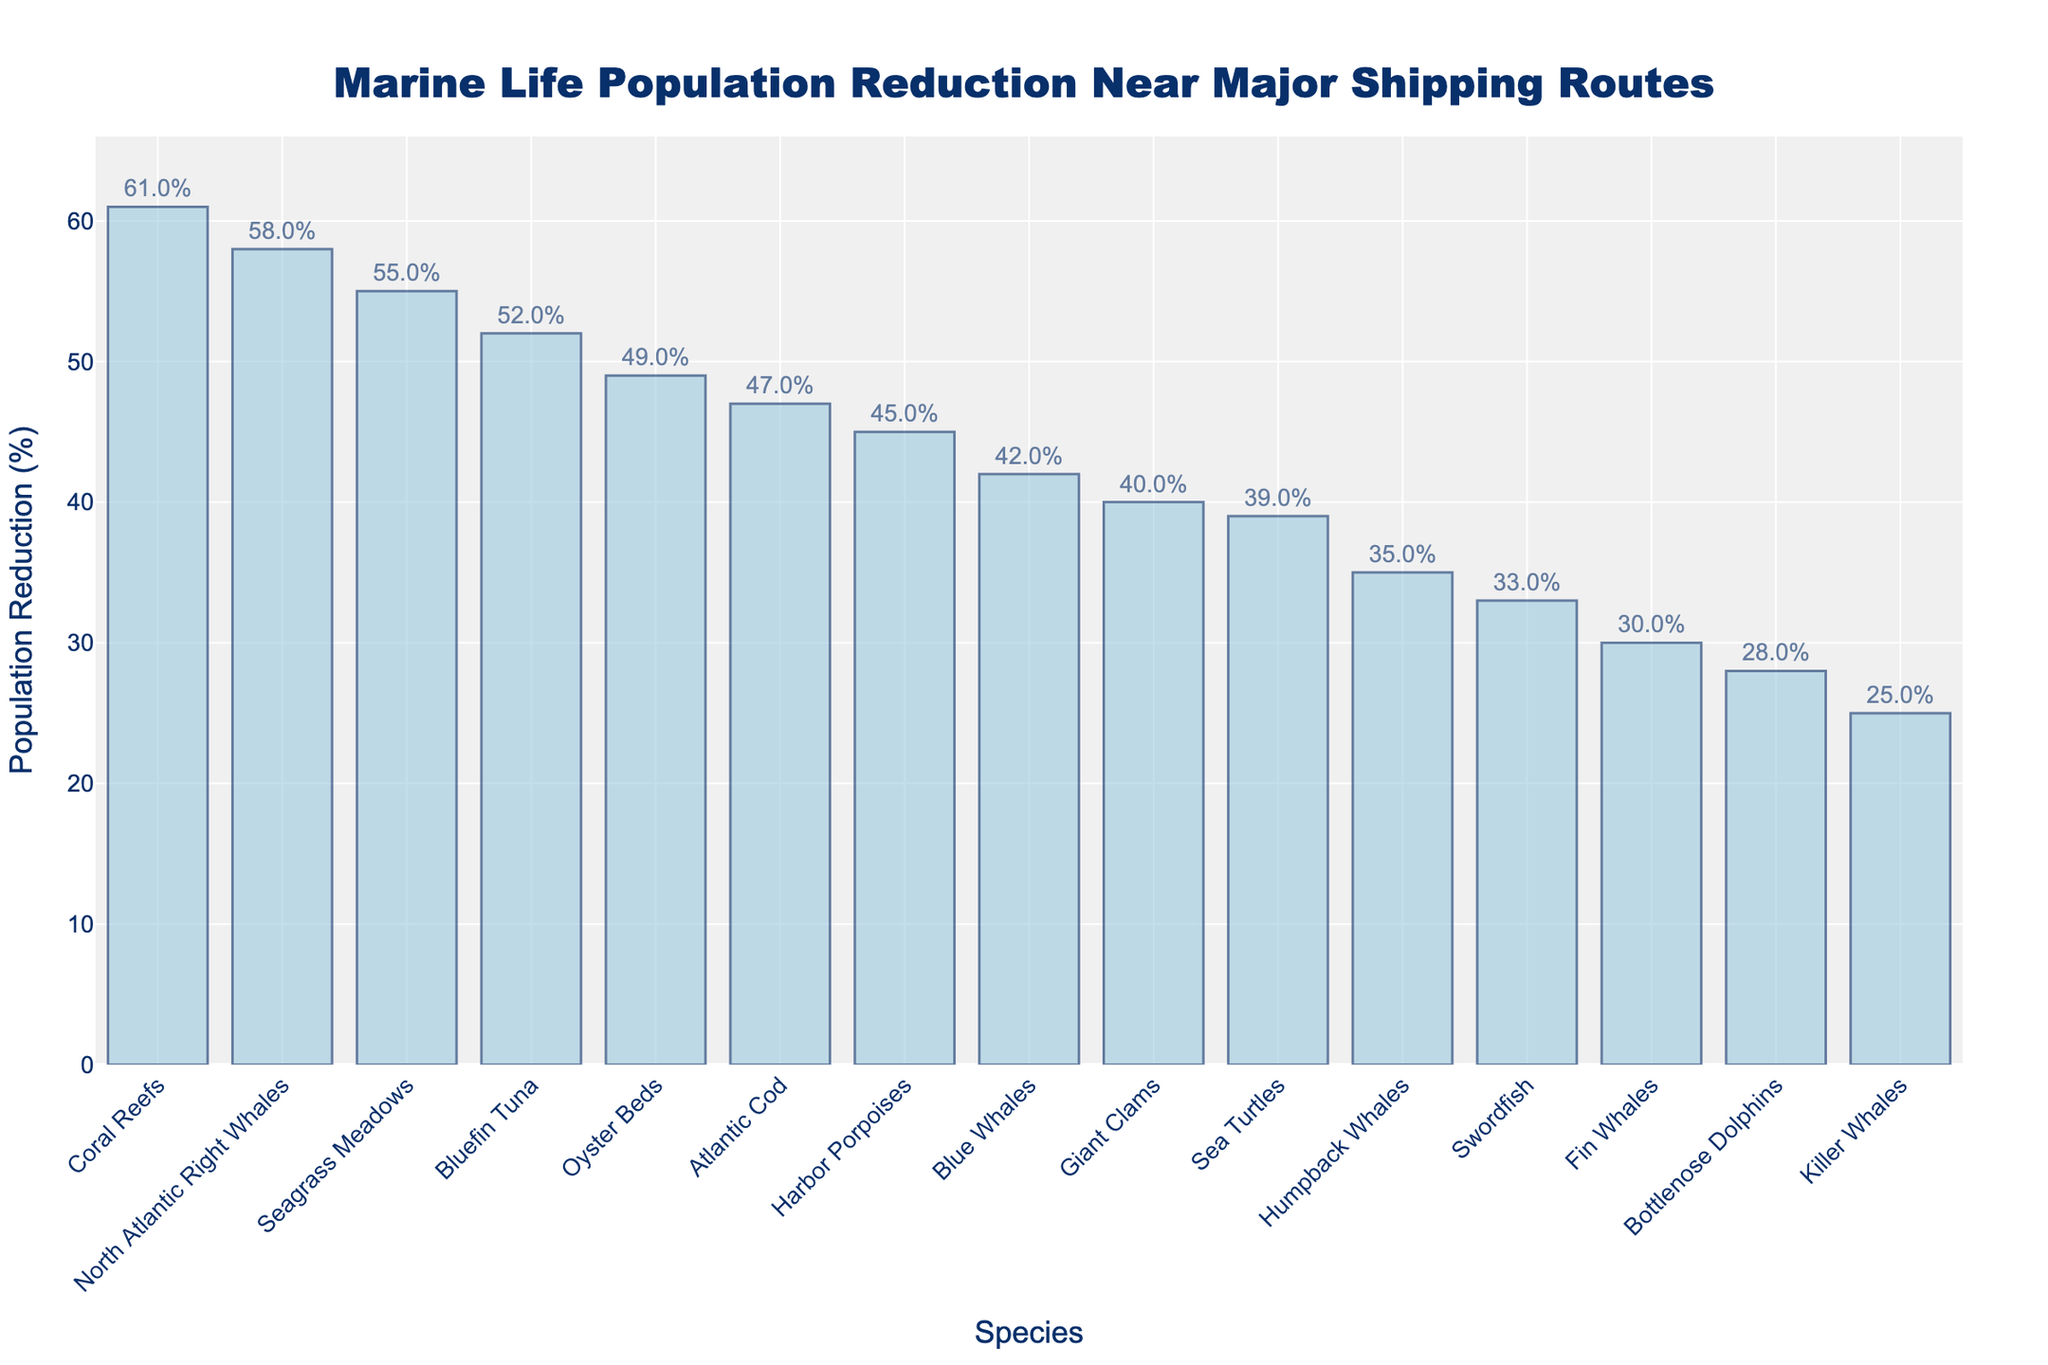What's the species with the highest population reduction? Look at the bar with the highest value. The title indicates that we are examining population reduction. The bar labeled "Coral Reefs" is the tallest.
Answer: Coral Reefs Which species has a lower population reduction, Humpback Whales or Blue Whales? Compare the heights of the bars labeled "Humpback Whales" and "Blue Whales". The bar for Humpback Whales is shorter.
Answer: Humpback Whales What is the average population reduction of Humpback Whales, Bottlenose Dolphins, and Swordfish? Add the population reductions for these species: 35% (Humpback Whales), 28% (Bottlenose Dolphins), and 33% (Swordfish). Then, divide by 3 to get the average: (35+28+33)/3 = 32%
Answer: 32% How much greater is the population reduction of Sea Turtles compared to Killer Whales? Subtract the population reduction percentage of Killer Whales from Sea Turtles: 39% (Sea Turtles) - 25% (Killer Whales) = 14%
Answer: 14% Is the population reduction for Bluefin Tuna closer to that of North Atlantic Right Whales or Atlantic Cod? The reduction for Bluefin Tuna is 52%. Compare this with the reductions for North Atlantic Right Whales (58%) and Atlantic Cod (47%). 52% (Bluefin Tuna) - 47% (Atlantic Cod) = 5%, and 58% (North Atlantic Right Whales) - 52% (Bluefin Tuna) = 6%. 5% is closer than 6%.
Answer: Atlantic Cod Which species has the smallest population reduction, and what is the percentage? Look for the shortest bar, which represents the species with the smallest reduction. The bar for "Killer Whales" is the shortest at 25%.
Answer: Killer Whales, 25% What is the total population reduction for Fin Whales, Harbor Porpoises, and Seagrass Meadows? Add the percentages for these species: 30% (Fin Whales), 45% (Harbor Porpoises), and 55% (Seagrass Meadows). The total is 30% + 45% + 55% = 130%.
Answer: 130% What's the difference in population reduction between the species with the highest and the lowest reductions? Subtract the lowest population reduction percentage (Killer Whales at 25%) from the highest (Coral Reefs at 61%). 61% - 25% = 36%.
Answer: 36% Which species have a population reduction greater than 50%? Identify the bars that exceed the 50% mark: North Atlantic Right Whales (58%), Bluefin Tuna (52%), Seagrass Meadows (55%), and Coral Reefs (61%).
Answer: North Atlantic Right Whales, Bluefin Tuna, Seagrass Meadows, Coral Reefs 